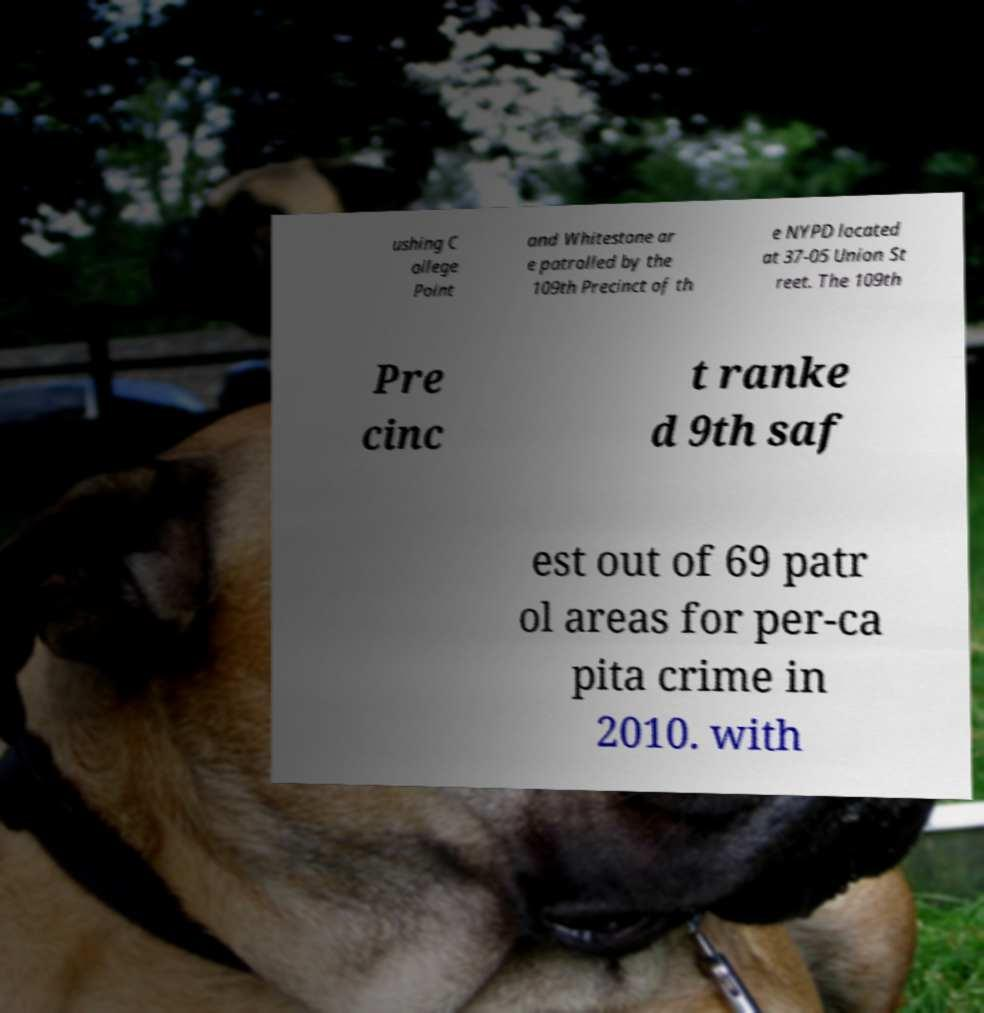For documentation purposes, I need the text within this image transcribed. Could you provide that? ushing C ollege Point and Whitestone ar e patrolled by the 109th Precinct of th e NYPD located at 37-05 Union St reet. The 109th Pre cinc t ranke d 9th saf est out of 69 patr ol areas for per-ca pita crime in 2010. with 